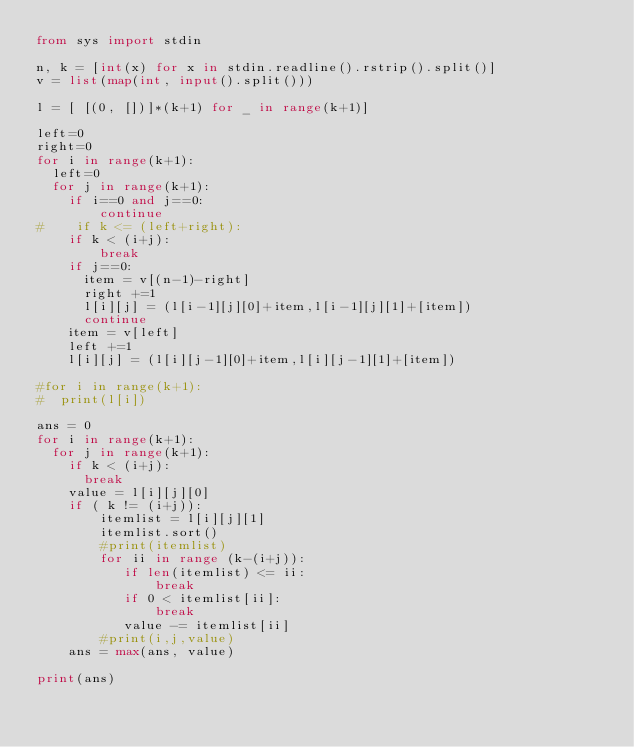Convert code to text. <code><loc_0><loc_0><loc_500><loc_500><_Python_>from sys import stdin

n, k = [int(x) for x in stdin.readline().rstrip().split()]
v = list(map(int, input().split()))

l = [ [(0, [])]*(k+1) for _ in range(k+1)]

left=0
right=0
for i in range(k+1):
  left=0
  for j in range(k+1):
    if i==0 and j==0:
        continue
#    if k <= (left+right):
    if k < (i+j):
        break
    if j==0:
      item = v[(n-1)-right]
      right +=1
      l[i][j] = (l[i-1][j][0]+item,l[i-1][j][1]+[item])
      continue
    item = v[left]
    left +=1
    l[i][j] = (l[i][j-1][0]+item,l[i][j-1][1]+[item])

#for i in range(k+1):
#  print(l[i])

ans = 0
for i in range(k+1):
  for j in range(k+1):
    if k < (i+j):
      break
    value = l[i][j][0]
    if ( k != (i+j)):
        itemlist = l[i][j][1]
        itemlist.sort()
        #print(itemlist)
        for ii in range (k-(i+j)):
           if len(itemlist) <= ii:
               break
           if 0 < itemlist[ii]:
               break
           value -= itemlist[ii]
        #print(i,j,value)
    ans = max(ans, value)

print(ans)
</code> 